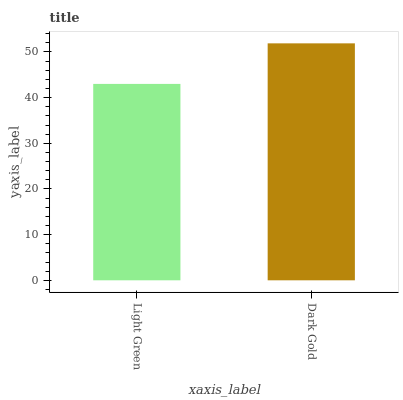Is Light Green the minimum?
Answer yes or no. Yes. Is Dark Gold the maximum?
Answer yes or no. Yes. Is Dark Gold the minimum?
Answer yes or no. No. Is Dark Gold greater than Light Green?
Answer yes or no. Yes. Is Light Green less than Dark Gold?
Answer yes or no. Yes. Is Light Green greater than Dark Gold?
Answer yes or no. No. Is Dark Gold less than Light Green?
Answer yes or no. No. Is Dark Gold the high median?
Answer yes or no. Yes. Is Light Green the low median?
Answer yes or no. Yes. Is Light Green the high median?
Answer yes or no. No. Is Dark Gold the low median?
Answer yes or no. No. 